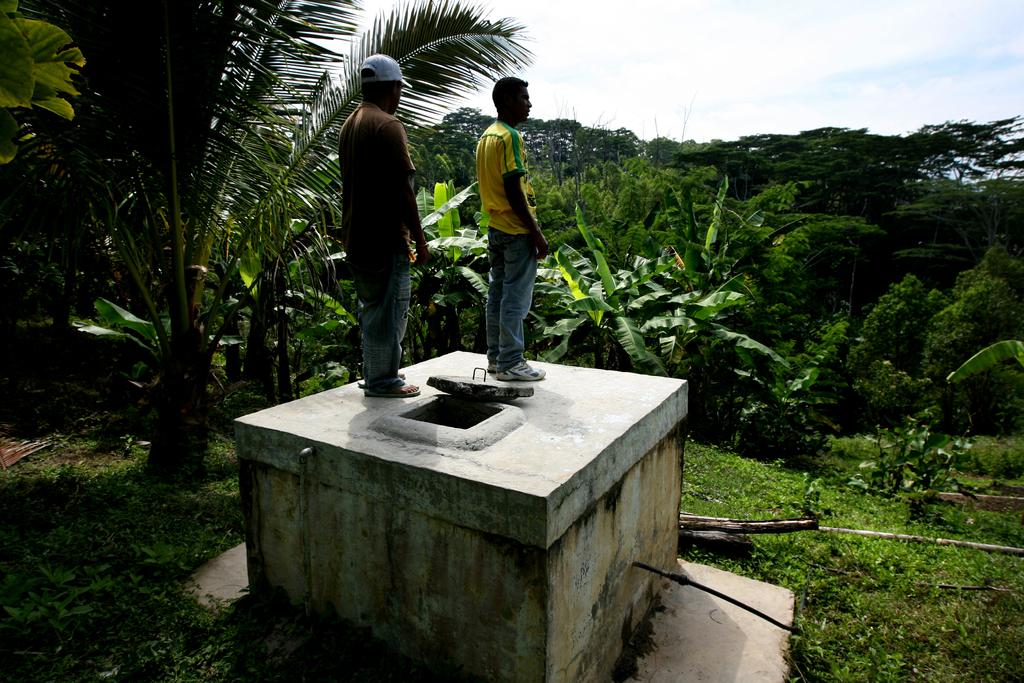What are the people doing in the image? The people are on a tank in the image. What type of vegetation is present on the ground in the image? There are trees and grass on the ground in the image. How would you describe the sky in the image? The sky is blue and cloudy in the image. What type of food is being handed to the beggar in the image? There is no beggar or food present in the image. What is the hand doing in the image? There is no hand visible in the image. 